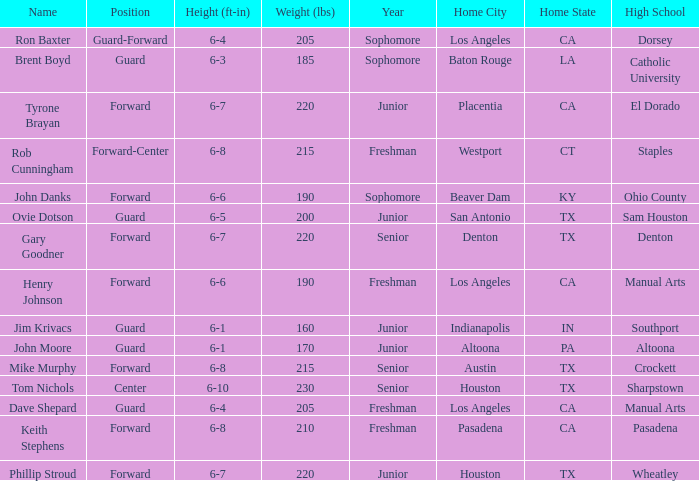What is the Name with a Year of junior, and a High School with wheatley? Phillip Stroud. 